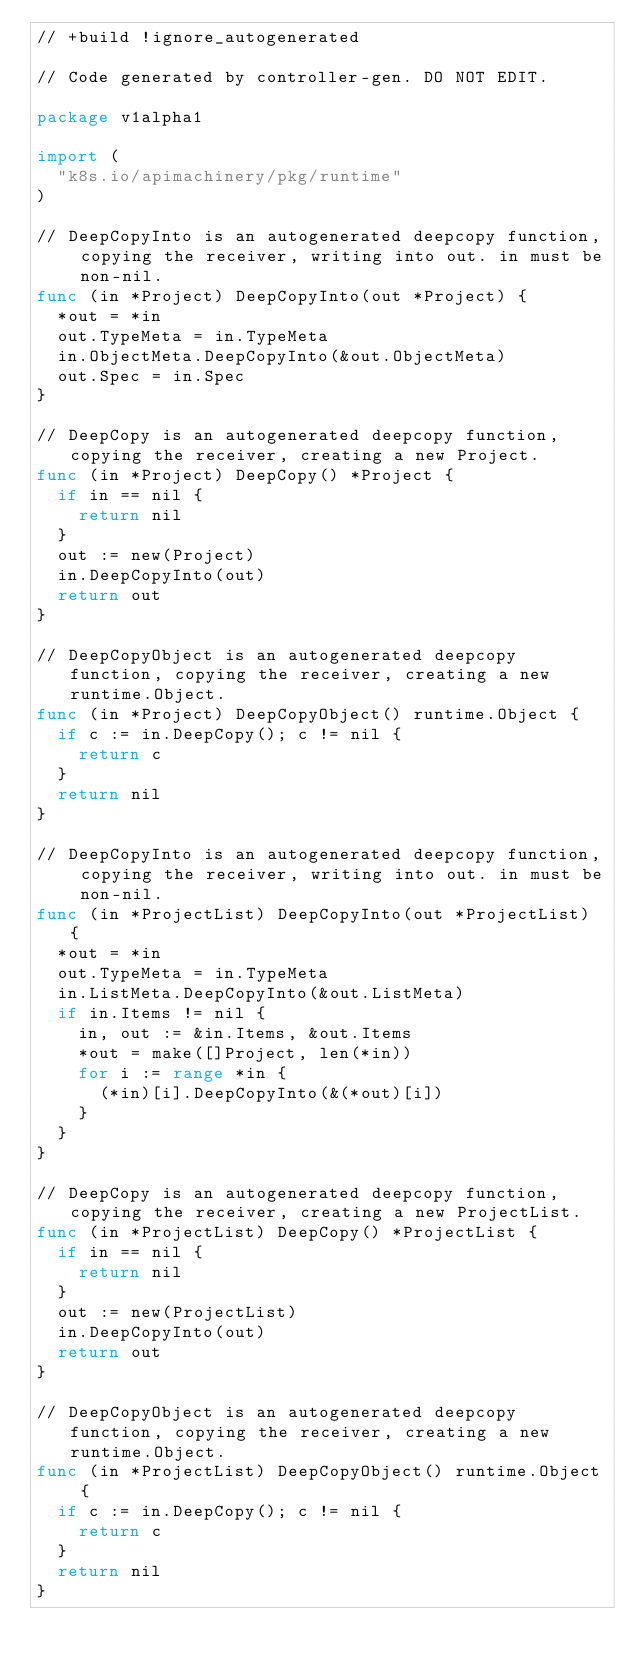Convert code to text. <code><loc_0><loc_0><loc_500><loc_500><_Go_>// +build !ignore_autogenerated

// Code generated by controller-gen. DO NOT EDIT.

package v1alpha1

import (
	"k8s.io/apimachinery/pkg/runtime"
)

// DeepCopyInto is an autogenerated deepcopy function, copying the receiver, writing into out. in must be non-nil.
func (in *Project) DeepCopyInto(out *Project) {
	*out = *in
	out.TypeMeta = in.TypeMeta
	in.ObjectMeta.DeepCopyInto(&out.ObjectMeta)
	out.Spec = in.Spec
}

// DeepCopy is an autogenerated deepcopy function, copying the receiver, creating a new Project.
func (in *Project) DeepCopy() *Project {
	if in == nil {
		return nil
	}
	out := new(Project)
	in.DeepCopyInto(out)
	return out
}

// DeepCopyObject is an autogenerated deepcopy function, copying the receiver, creating a new runtime.Object.
func (in *Project) DeepCopyObject() runtime.Object {
	if c := in.DeepCopy(); c != nil {
		return c
	}
	return nil
}

// DeepCopyInto is an autogenerated deepcopy function, copying the receiver, writing into out. in must be non-nil.
func (in *ProjectList) DeepCopyInto(out *ProjectList) {
	*out = *in
	out.TypeMeta = in.TypeMeta
	in.ListMeta.DeepCopyInto(&out.ListMeta)
	if in.Items != nil {
		in, out := &in.Items, &out.Items
		*out = make([]Project, len(*in))
		for i := range *in {
			(*in)[i].DeepCopyInto(&(*out)[i])
		}
	}
}

// DeepCopy is an autogenerated deepcopy function, copying the receiver, creating a new ProjectList.
func (in *ProjectList) DeepCopy() *ProjectList {
	if in == nil {
		return nil
	}
	out := new(ProjectList)
	in.DeepCopyInto(out)
	return out
}

// DeepCopyObject is an autogenerated deepcopy function, copying the receiver, creating a new runtime.Object.
func (in *ProjectList) DeepCopyObject() runtime.Object {
	if c := in.DeepCopy(); c != nil {
		return c
	}
	return nil
}
</code> 